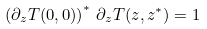Convert formula to latex. <formula><loc_0><loc_0><loc_500><loc_500>\left ( \partial _ { z } T ( 0 , 0 ) \right ) ^ { * } \, \partial _ { z } T ( z , z ^ { * } ) = 1</formula> 